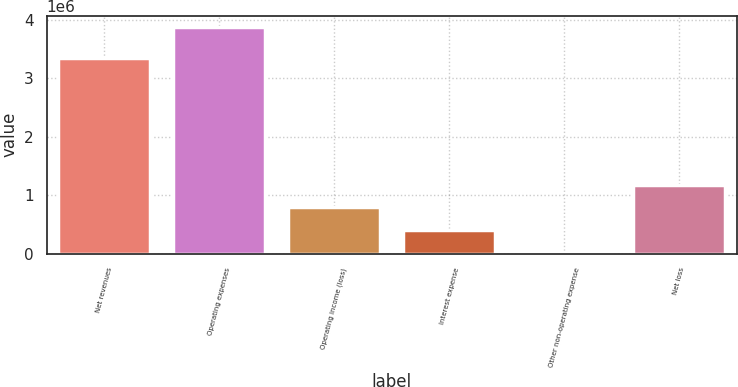<chart> <loc_0><loc_0><loc_500><loc_500><bar_chart><fcel>Net revenues<fcel>Operating expenses<fcel>Operating income (loss)<fcel>Interest expense<fcel>Other non-operating expense<fcel>Net loss<nl><fcel>3.34563e+06<fcel>3.87744e+06<fcel>797450<fcel>412450<fcel>27451<fcel>1.18245e+06<nl></chart> 